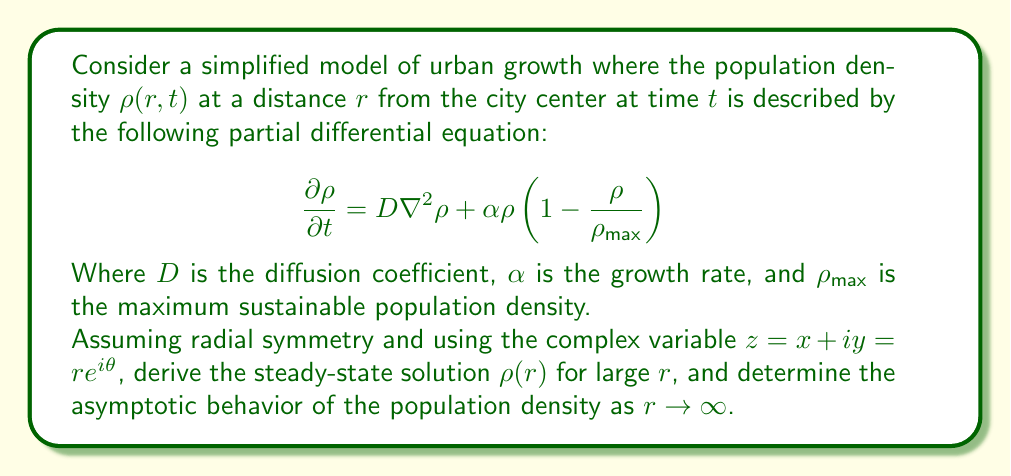What is the answer to this math problem? To solve this problem, we'll follow these steps:

1) First, we need to rewrite the equation in polar coordinates due to radial symmetry:

   $$\frac{\partial \rho}{\partial t} = D (\frac{\partial^2 \rho}{\partial r^2} + \frac{1}{r}\frac{\partial \rho}{\partial r}) + \alpha \rho (1 - \frac{\rho}{\rho_{max}})$$

2) For the steady-state solution, we set $\frac{\partial \rho}{\partial t} = 0$:

   $$0 = D (\frac{d^2 \rho}{dr^2} + \frac{1}{r}\frac{d\rho}{dr}) + \alpha \rho (1 - \frac{\rho}{\rho_{max}})$$

3) For large $r$, we can neglect the $\frac{1}{r}\frac{d\rho}{dr}$ term:

   $$0 \approx D \frac{d^2 \rho}{dr^2} + \alpha \rho (1 - \frac{\rho}{\rho_{max}})$$

4) We can simplify this further by introducing dimensionless variables:

   Let $\rho = \rho_{max} u$ and $r = \sqrt{\frac{D}{\alpha}} s$

   This transforms our equation to:

   $$\frac{d^2 u}{ds^2} + u(1-u) = 0$$

5) For large $s$ (equivalent to large $r$), we expect $u$ to be small. So we can neglect the $u^2$ term:

   $$\frac{d^2 u}{ds^2} + u \approx 0$$

6) This is a linear second-order ODE with constant coefficients. The general solution is:

   $$u = Ae^{is} + Be^{-is}$$

   Where $A$ and $B$ are complex constants.

7) Transforming back to our original variables:

   $$\rho(r) = \rho_{max}(Ae^{i\sqrt{\frac{\alpha}{D}}r} + Be^{-i\sqrt{\frac{\alpha}{D}}r})$$

8) The asymptotic behavior as $r \to \infty$ can be described using the complex variable $z = re^{i\theta}$:

   $$\rho(z) \sim \rho_{max}Ae^{i\sqrt{\frac{\alpha}{D}}z} \quad \text{as} \quad |z| \to \infty$$

   This represents a spiraling wave-like pattern in the complex plane.
Answer: The steady-state solution for large $r$ is:

$$\rho(r) = \rho_{max}(Ae^{i\sqrt{\frac{\alpha}{D}}r} + Be^{-i\sqrt{\frac{\alpha}{D}}r})$$

The asymptotic behavior as $r \to \infty$ in the complex plane is:

$$\rho(z) \sim \rho_{max}Ae^{i\sqrt{\frac{\alpha}{D}}z} \quad \text{as} \quad |z| \to \infty$$

This represents a spiraling wave-like pattern with decreasing amplitude as distance from the city center increases. 